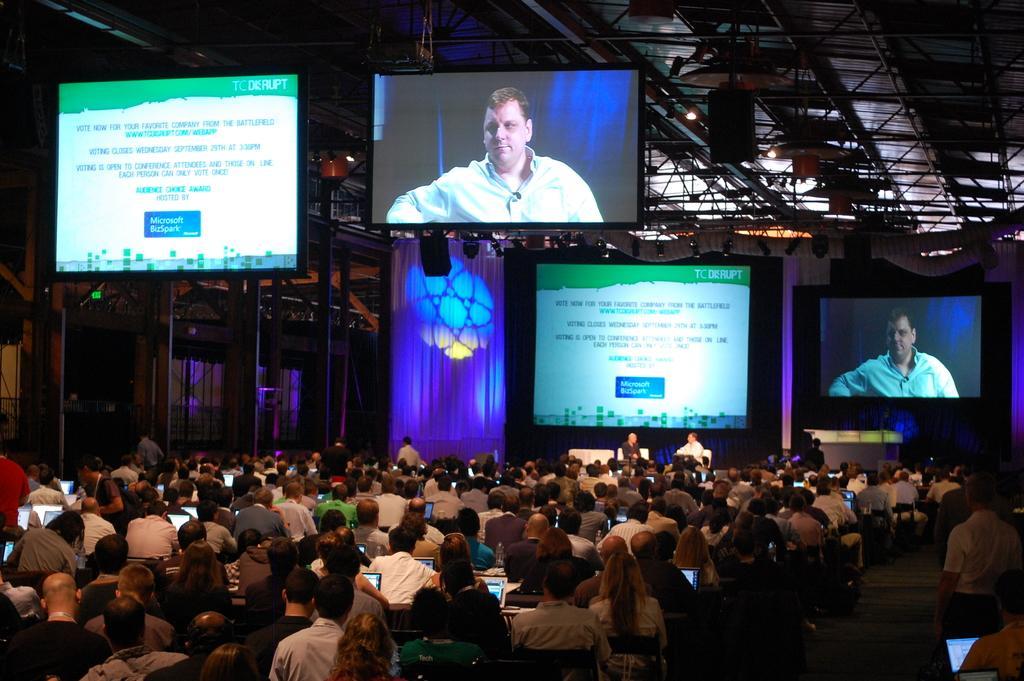Please provide a concise description of this image. In the given image i can see the inside view of the auditorium that includes led tv,audience,lights and curtains. 